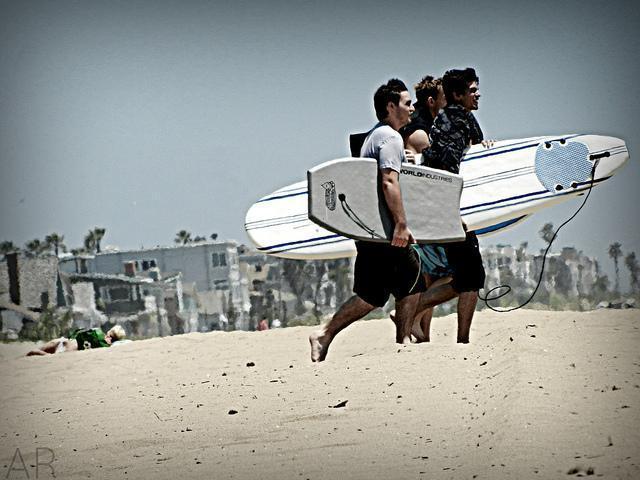How many surfboards can be seen?
Give a very brief answer. 2. How many people are there?
Give a very brief answer. 3. 